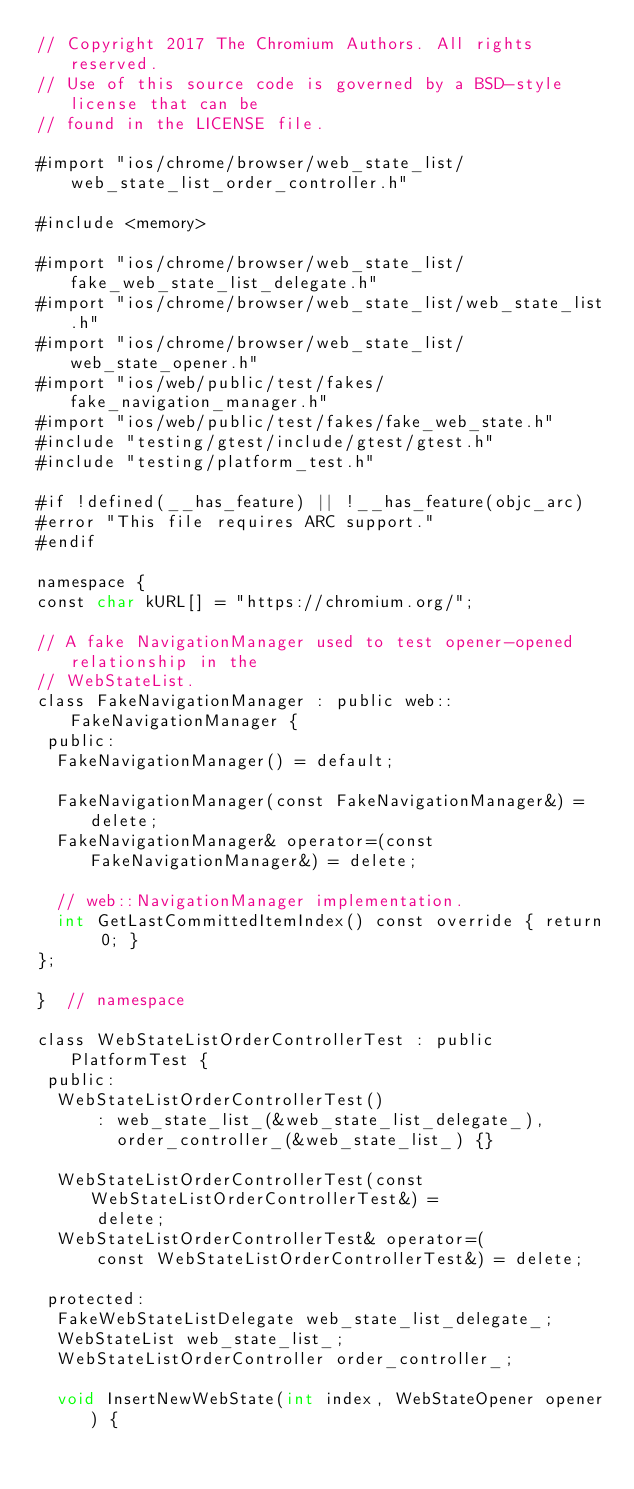<code> <loc_0><loc_0><loc_500><loc_500><_ObjectiveC_>// Copyright 2017 The Chromium Authors. All rights reserved.
// Use of this source code is governed by a BSD-style license that can be
// found in the LICENSE file.

#import "ios/chrome/browser/web_state_list/web_state_list_order_controller.h"

#include <memory>

#import "ios/chrome/browser/web_state_list/fake_web_state_list_delegate.h"
#import "ios/chrome/browser/web_state_list/web_state_list.h"
#import "ios/chrome/browser/web_state_list/web_state_opener.h"
#import "ios/web/public/test/fakes/fake_navigation_manager.h"
#import "ios/web/public/test/fakes/fake_web_state.h"
#include "testing/gtest/include/gtest/gtest.h"
#include "testing/platform_test.h"

#if !defined(__has_feature) || !__has_feature(objc_arc)
#error "This file requires ARC support."
#endif

namespace {
const char kURL[] = "https://chromium.org/";

// A fake NavigationManager used to test opener-opened relationship in the
// WebStateList.
class FakeNavigationManager : public web::FakeNavigationManager {
 public:
  FakeNavigationManager() = default;

  FakeNavigationManager(const FakeNavigationManager&) = delete;
  FakeNavigationManager& operator=(const FakeNavigationManager&) = delete;

  // web::NavigationManager implementation.
  int GetLastCommittedItemIndex() const override { return 0; }
};

}  // namespace

class WebStateListOrderControllerTest : public PlatformTest {
 public:
  WebStateListOrderControllerTest()
      : web_state_list_(&web_state_list_delegate_),
        order_controller_(&web_state_list_) {}

  WebStateListOrderControllerTest(const WebStateListOrderControllerTest&) =
      delete;
  WebStateListOrderControllerTest& operator=(
      const WebStateListOrderControllerTest&) = delete;

 protected:
  FakeWebStateListDelegate web_state_list_delegate_;
  WebStateList web_state_list_;
  WebStateListOrderController order_controller_;

  void InsertNewWebState(int index, WebStateOpener opener) {</code> 